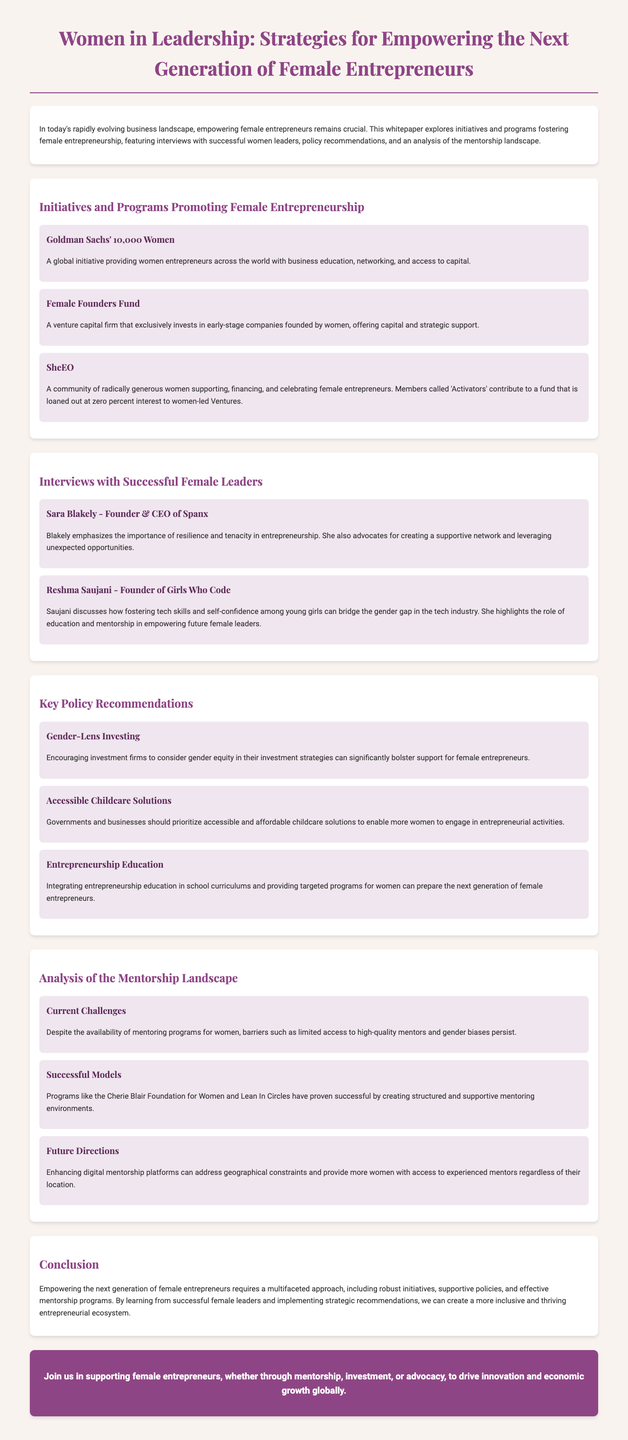what is the title of the whitepaper? The title of the whitepaper is explicitly mentioned in the document's header.
Answer: Women in Leadership: Strategies for Empowering the Next Generation of Female Entrepreneurs what is one initiative promoting female entrepreneurship mentioned in the document? The document lists several initiatives, one of which is explicitly stated.
Answer: Goldman Sachs' 10,000 Women who is the founder of Girls Who Code? The interview section names the founder of Girls Who Code.
Answer: Reshma Saujani what is one key policy recommendation for supporting female entrepreneurs? The document includes multiple policy recommendations, one of which is provided.
Answer: Accessible Childcare Solutions what aspect of the mentorship landscape is discussed in the document? The document covers several aspects of the mentorship landscape, highlighting unique features.
Answer: Current Challenges how many initiatives are mentioned in the section on initiatives and programs? The document lists three specific initiatives promoting female entrepreneurship.
Answer: Three what successful mentoring program is highlighted for creating structured environments? The document mentions a specific program that has proven successful in mentoring.
Answer: Cherie Blair Foundation for Women what does the conclusion emphasize as necessary for empowering female entrepreneurs? The conclusion summarizes the key components required for empowerment, as stated.
Answer: Multifaceted approach 